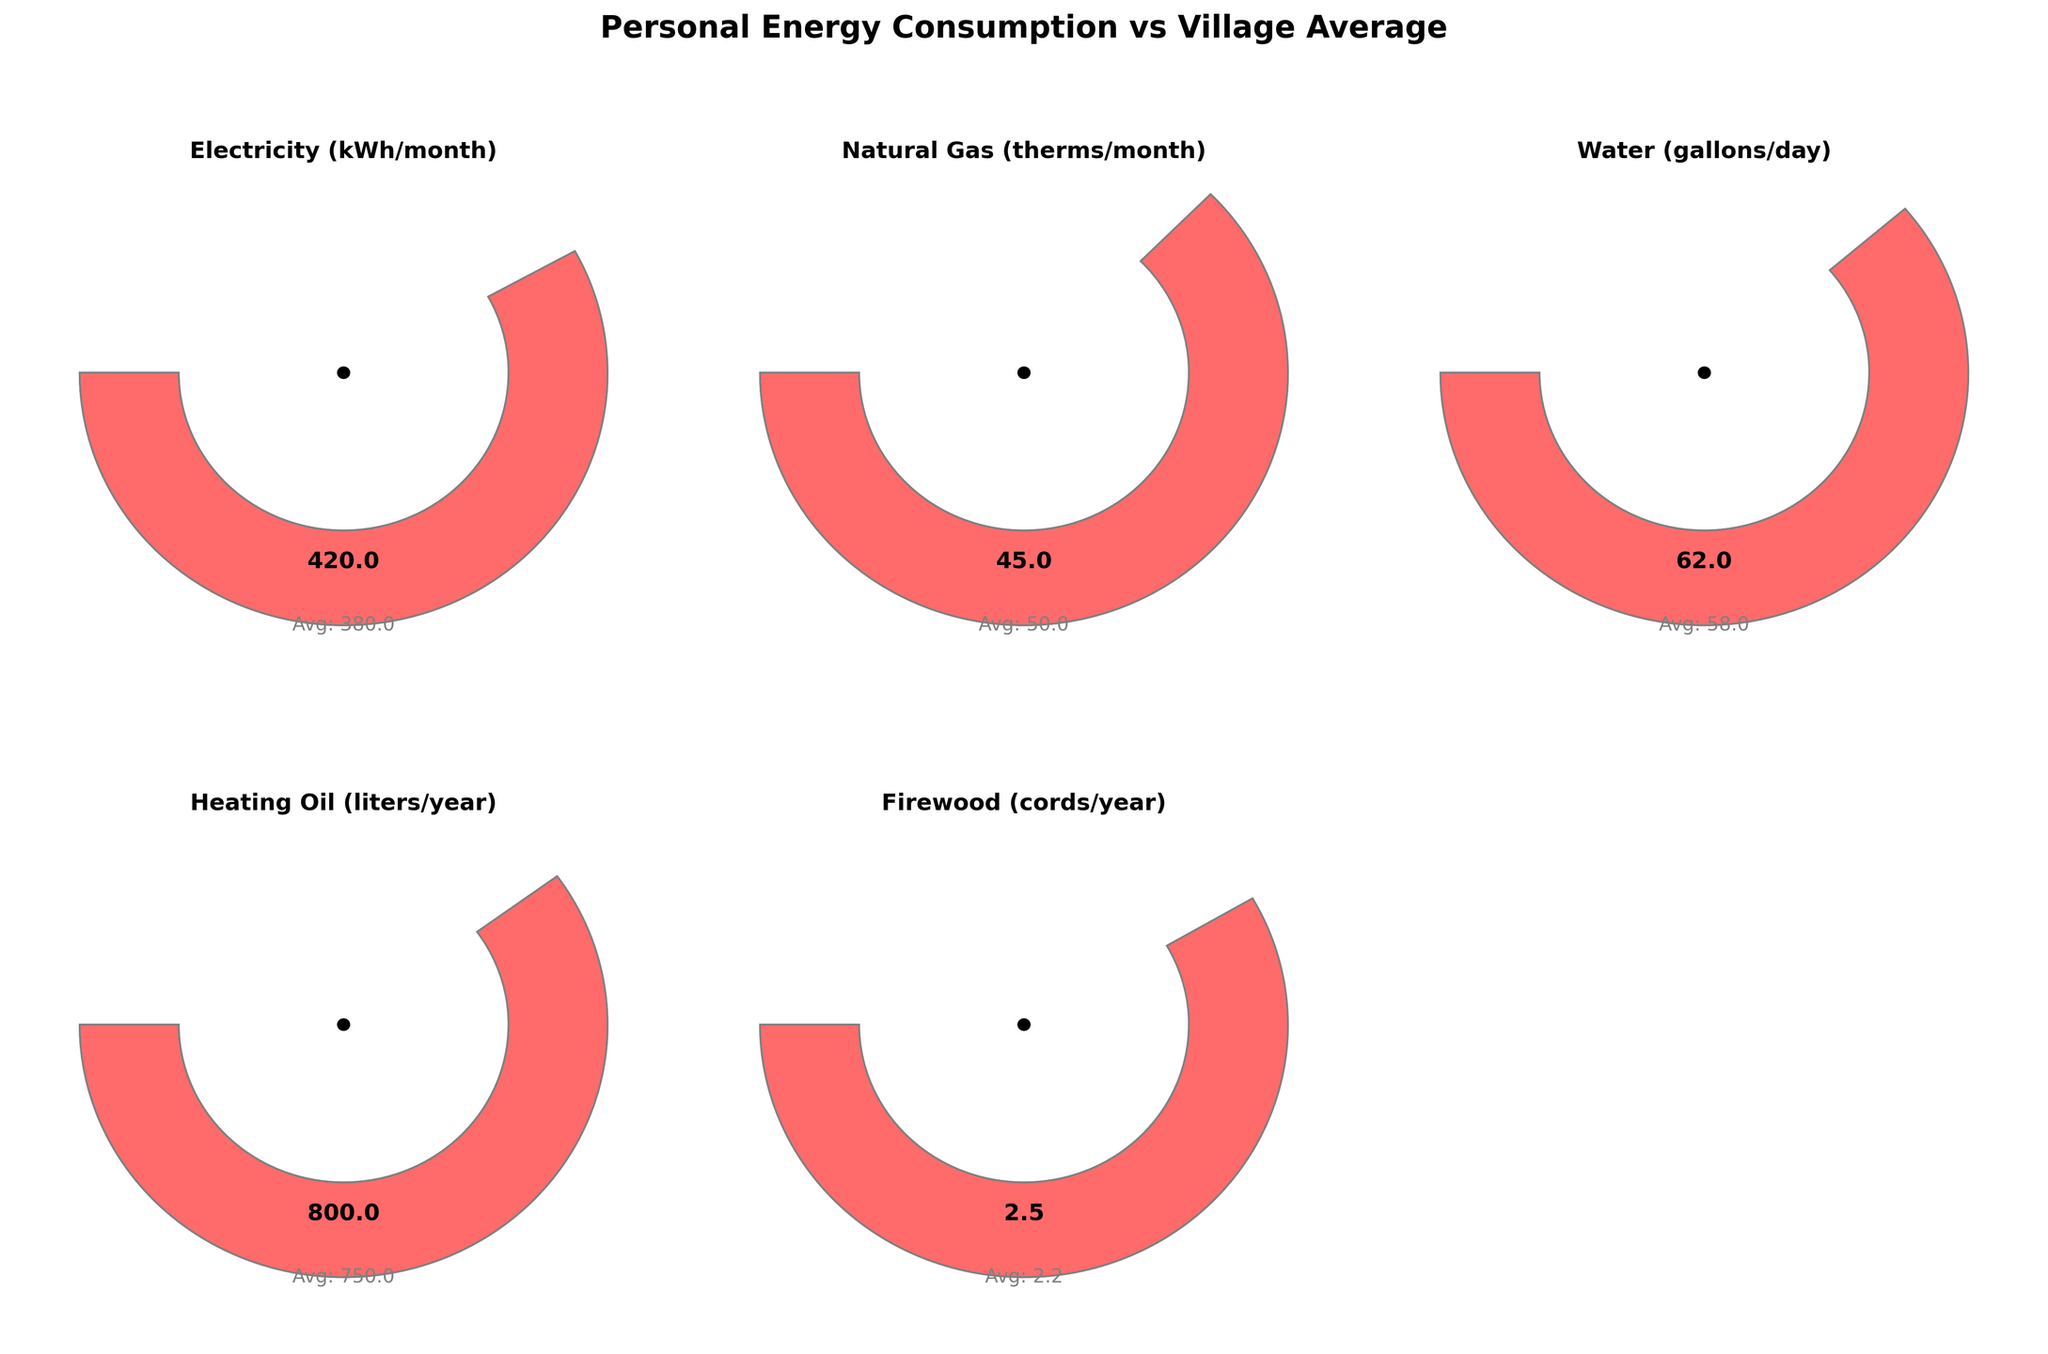What's the title of the figure? The title is clearly shown at the top of the figure in bold, larger font size: "Personal Energy Consumption vs Village Average"
Answer: Personal Energy Consumption vs Village Average How many categories are shown in the gauge charts? By counting the individual gauges, which are placed in separate subplots across the figure, we can see there are five categories displayed
Answer: 5 Which category has the highest personal consumption compared to the village average? Compare the angles of the red segments for personal consumption with the grey segments for the village average across all gauges. The Electricity (kWh/month) gauge has the most prominent red segment extending beyond the average
Answer: Electricity (kWh/month) What's the difference between personal and village average Electricity consumption? The figure indicates 420 kWh/month for personal consumption and 380 kWh/month for the village average. Subtract the village average from the personal value: 420 - 380 = 40
Answer: 40 Which category does personal consumption exceed the village average the most? The comparison involves finding the category with the largest difference where personal consumption value exceeds the village average. As visually observed, the largest difference is observed in the Electricity category 420 - 380 = 40 kWh
Answer: Electricity (kWh/month) Which categories have personal consumption less than the village average? Identify the gauges where the red segments (personal consumption) are shorter than the grey segments (village average). Natural Gas (45 vs 50 therms) and Firewood (2.5 vs 2.2 cords). In both, the personal consumption is less than the average.
Answer: Natural Gas, Firewood In which category is personal consumption closest to the village average? Check each gauge to see which red segment is closest in length to the corresponding grey segment. Water (62 vs 58 gallons/day) has the smallest difference of 4
Answer: Water (gallons/day) For the Heating Oil category, what's the ratio of personal consumption to village average? The figure shows 800 liters/year for personal consumption and 750 liters/year for the village average. The ratio can be found as 800/750 which simplifies to 1.067
Answer: 1.067 Which category has the smallest deviation from the average in numerical value? Calculate the numerical deviation for each category by subtracting village average from personal consumption. The smallest deviation is in Water with 4 gallons/day difference
Answer: Water (gallons/day) 